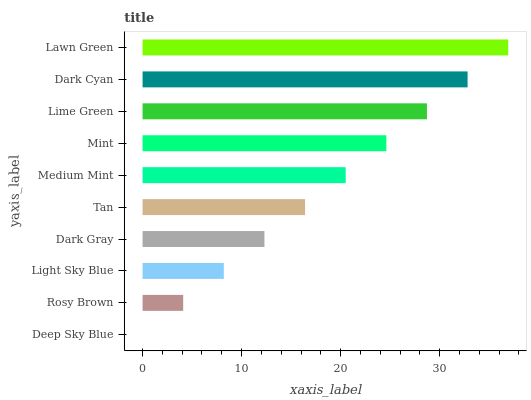Is Deep Sky Blue the minimum?
Answer yes or no. Yes. Is Lawn Green the maximum?
Answer yes or no. Yes. Is Rosy Brown the minimum?
Answer yes or no. No. Is Rosy Brown the maximum?
Answer yes or no. No. Is Rosy Brown greater than Deep Sky Blue?
Answer yes or no. Yes. Is Deep Sky Blue less than Rosy Brown?
Answer yes or no. Yes. Is Deep Sky Blue greater than Rosy Brown?
Answer yes or no. No. Is Rosy Brown less than Deep Sky Blue?
Answer yes or no. No. Is Medium Mint the high median?
Answer yes or no. Yes. Is Tan the low median?
Answer yes or no. Yes. Is Light Sky Blue the high median?
Answer yes or no. No. Is Rosy Brown the low median?
Answer yes or no. No. 